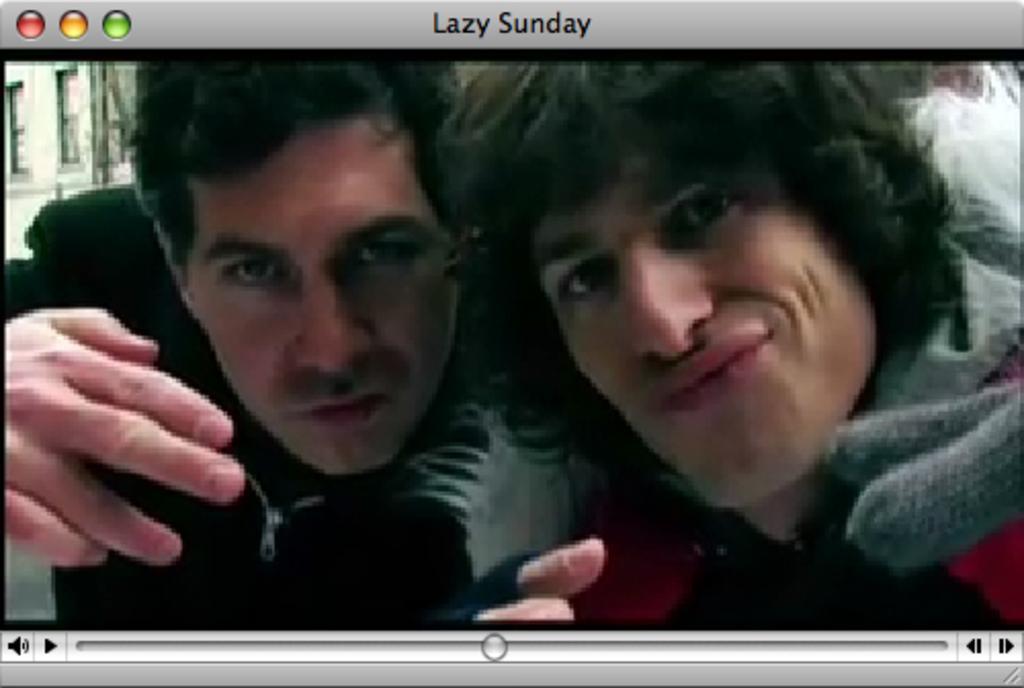How would you summarize this image in a sentence or two? This is a picture of the screen, where there are two persons in the image. 